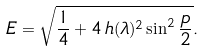<formula> <loc_0><loc_0><loc_500><loc_500>E = \sqrt { \frac { 1 } { 4 } + 4 \, h ( \lambda ) ^ { 2 } \sin ^ { 2 } \frac { p } { 2 } } .</formula> 